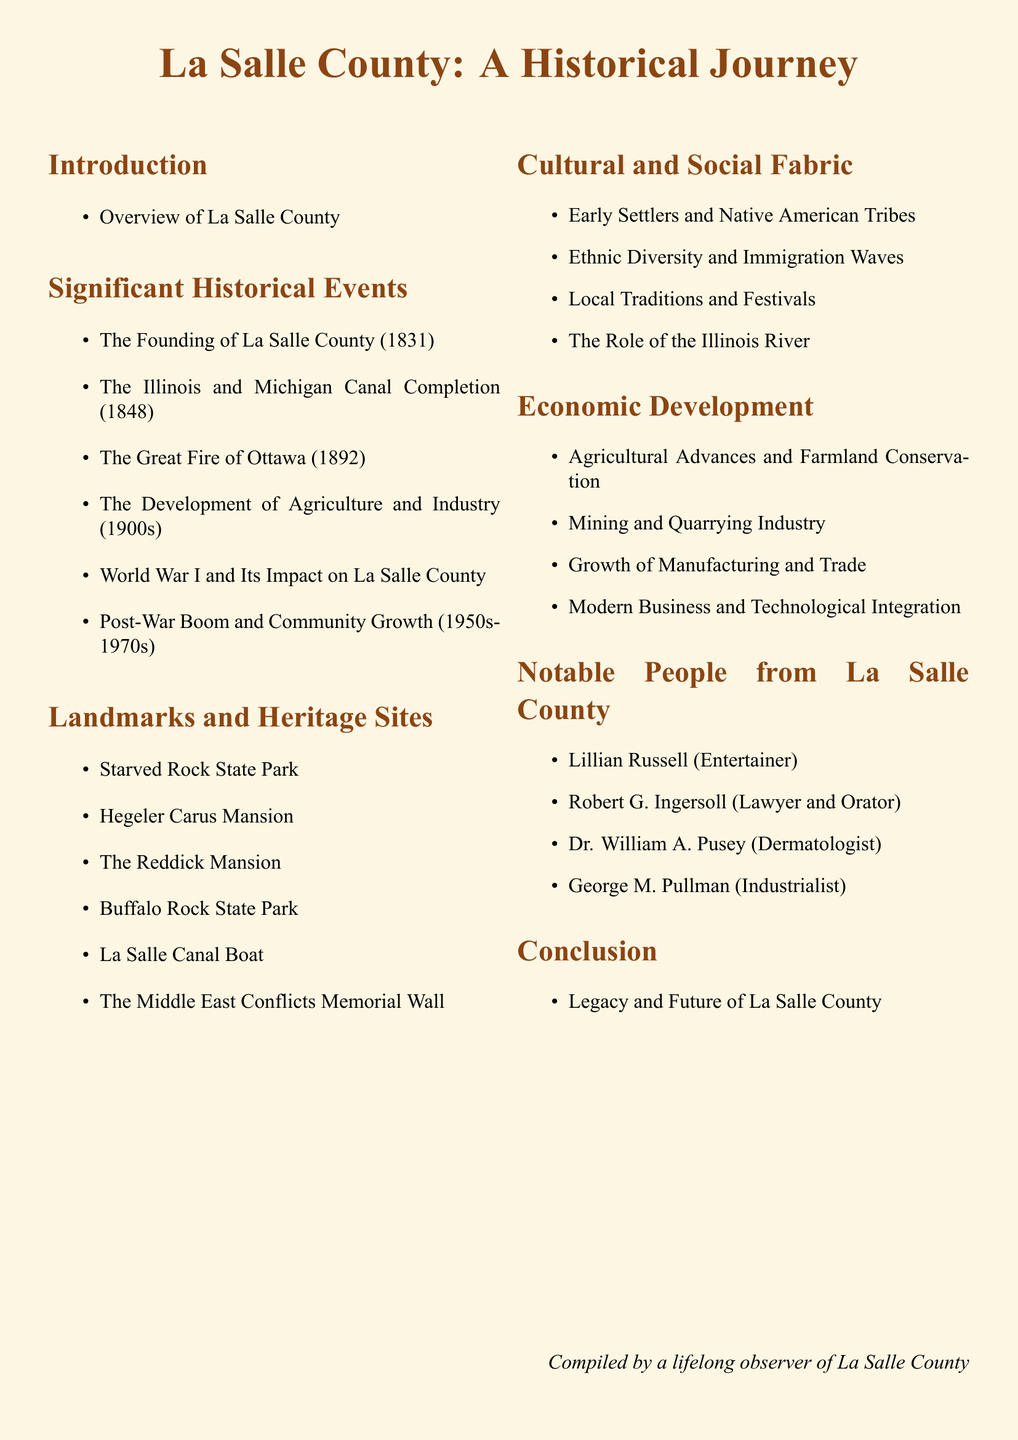What year was La Salle County founded? The document states that La Salle County was founded in the year 1831.
Answer: 1831 What significant event occurred in 1848? The completion of the Illinois and Michigan Canal took place in 1848, as mentioned in the document.
Answer: Illinois and Michigan Canal Completion Which landmark is mentioned first? The first landmark listed in the document is Starved Rock State Park.
Answer: Starved Rock State Park Who is noted as a notable entertainer from La Salle County? The document lists Lillian Russell as a notable entertainer from La Salle County.
Answer: Lillian Russell What was the impact of World War I on La Salle County? The document states the impact of World War I on La Salle County is described under the significant historical events section.
Answer: Impact on La Salle County What trend is discussed in the Economic Development section? The Economic Development section discusses the trend of Agricultural Advances and Farmland Conservation.
Answer: Agricultural Advances and Farmland Conservation What decade is specified for the post-war boom and community growth? The post-war boom and community growth are specified for the decades of the 1950s to the 1970s.
Answer: 1950s-1970s Which section covers local traditions? Local traditions are covered under the Cultural and Social Fabric section of the document.
Answer: Cultural and Social Fabric What is the last note found in the document? The last note in the document is about the legacy and future of La Salle County.
Answer: Legacy and Future of La Salle County 